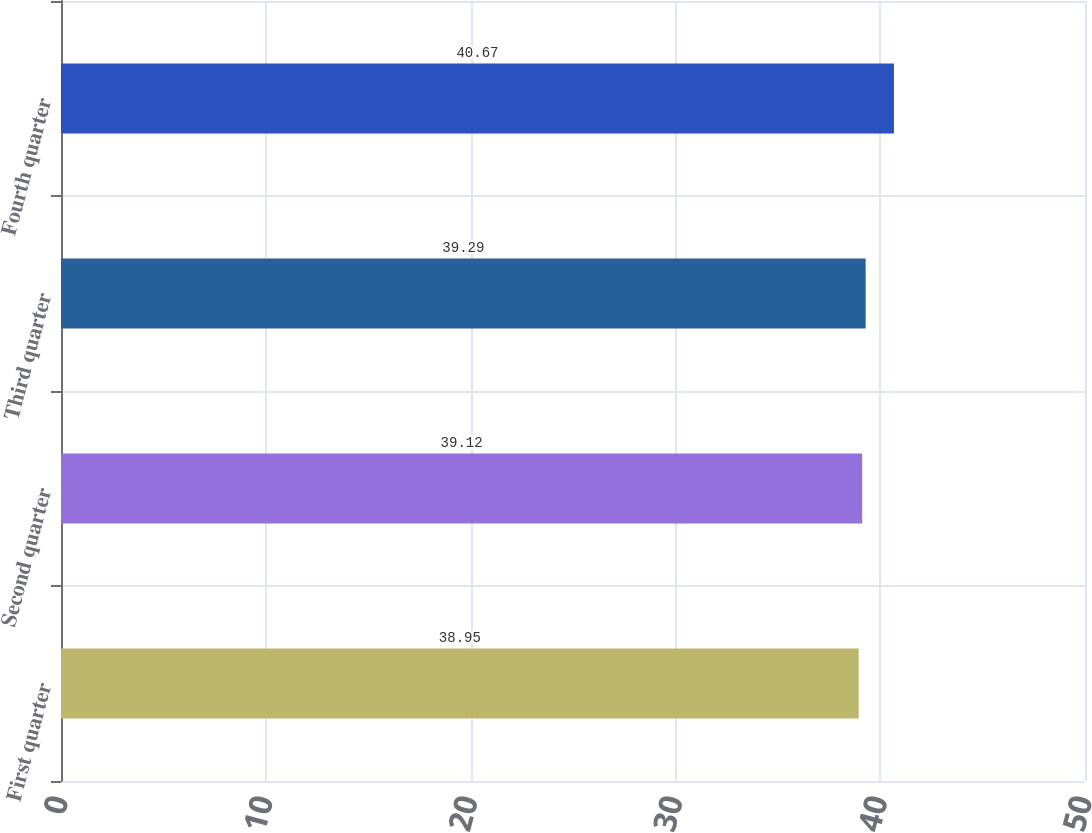<chart> <loc_0><loc_0><loc_500><loc_500><bar_chart><fcel>First quarter<fcel>Second quarter<fcel>Third quarter<fcel>Fourth quarter<nl><fcel>38.95<fcel>39.12<fcel>39.29<fcel>40.67<nl></chart> 